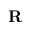<formula> <loc_0><loc_0><loc_500><loc_500>R</formula> 